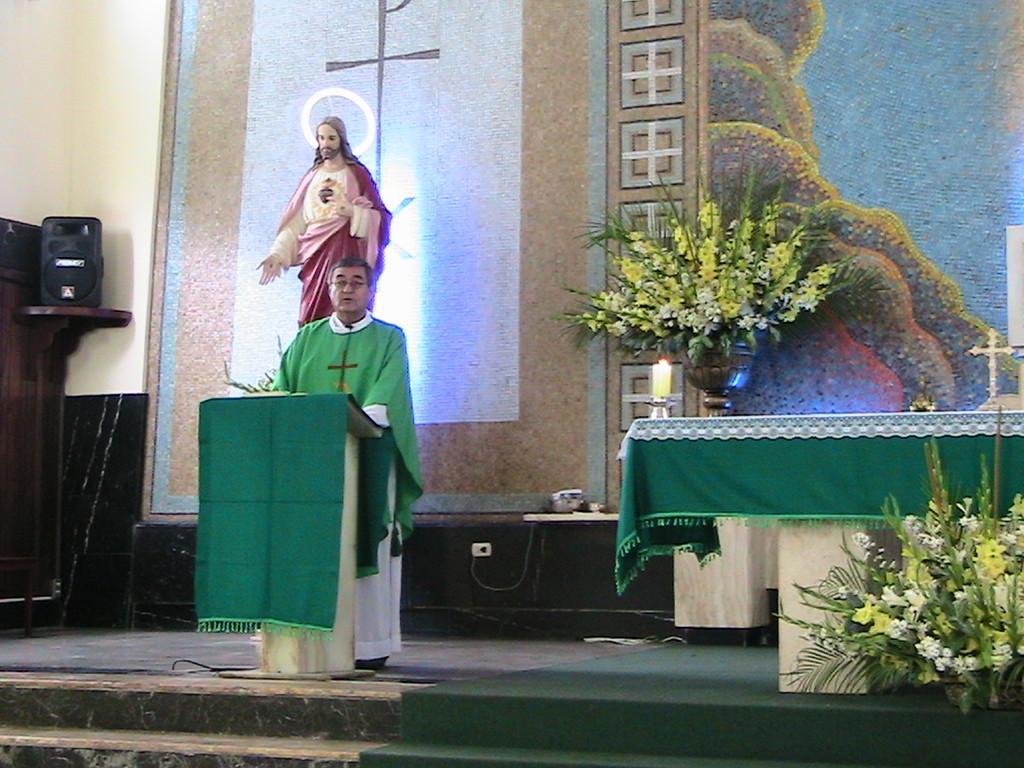Describe this image in one or two sentences. In the image there is a person in green dress standing in front of dias on a stage with a table. flower pot,candle stand and a statue behind him in front of the wall, on the left side there is a speaker with table. 